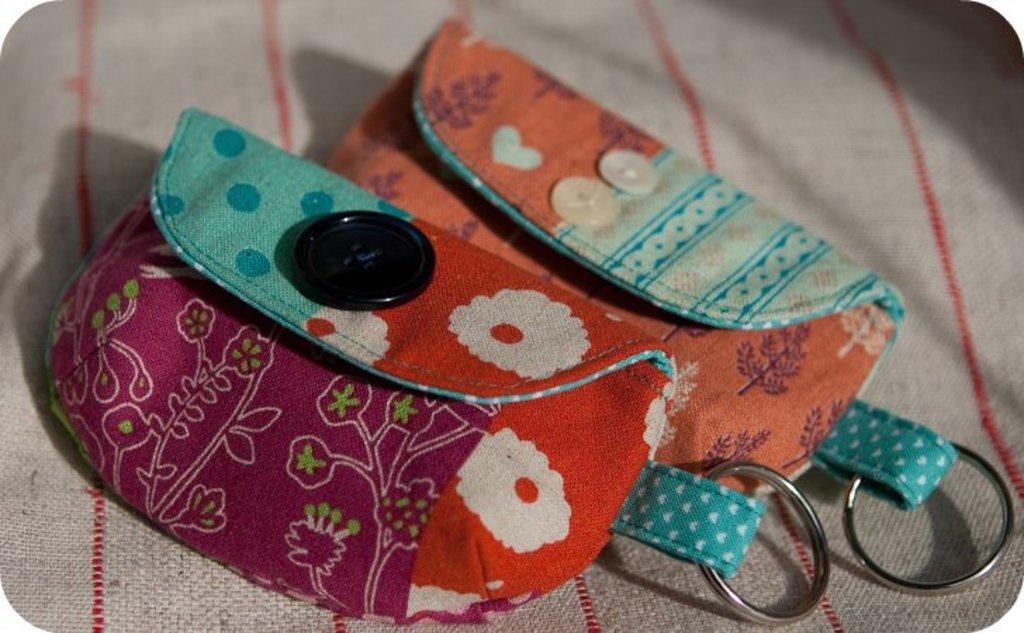How many pouches are visible in the image? There are two pouches in the image. Where are the pouches located? The pouches are placed on a mat. What type of dock can be seen in the image? There is no dock present in the image; it only features two pouches placed on a mat. How many clams are visible in the image? There are no clams present in the image. 